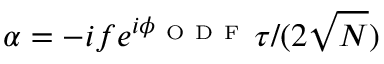Convert formula to latex. <formula><loc_0><loc_0><loc_500><loc_500>\alpha = - i f e ^ { i \phi _ { O D F } } \tau / ( 2 \sqrt { N } )</formula> 